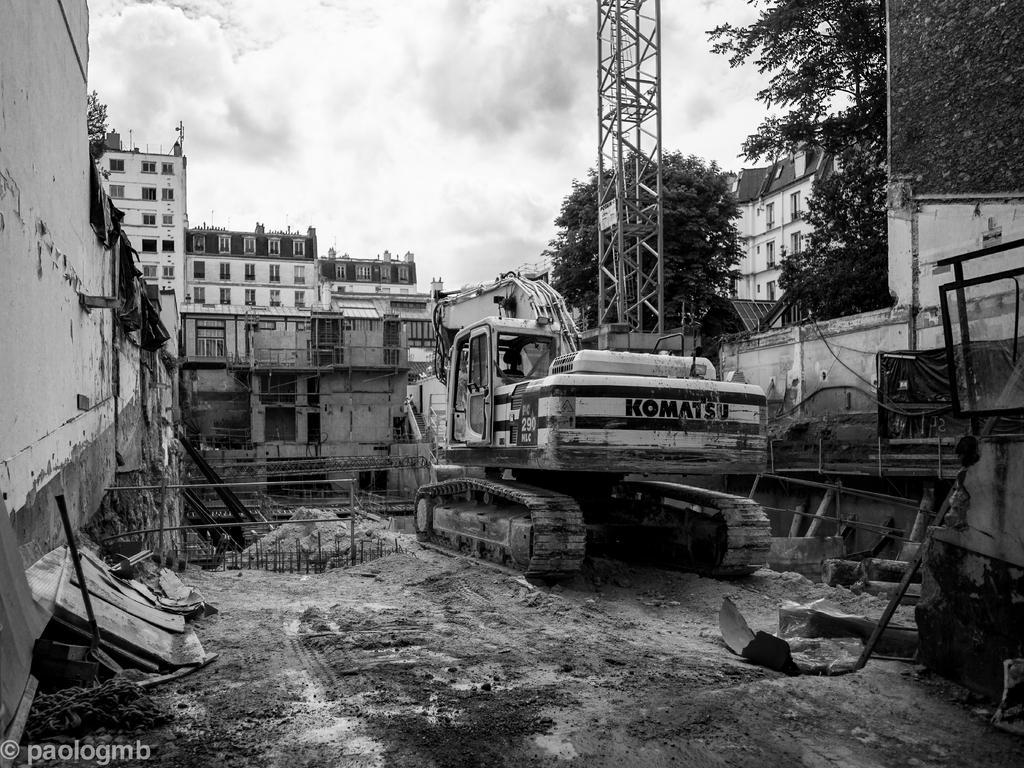Could you give a brief overview of what you see in this image? In this picture we can see a vehicle on the ground and in the background we can see buildings, trees, sky, in the bottom left we can see some text. 